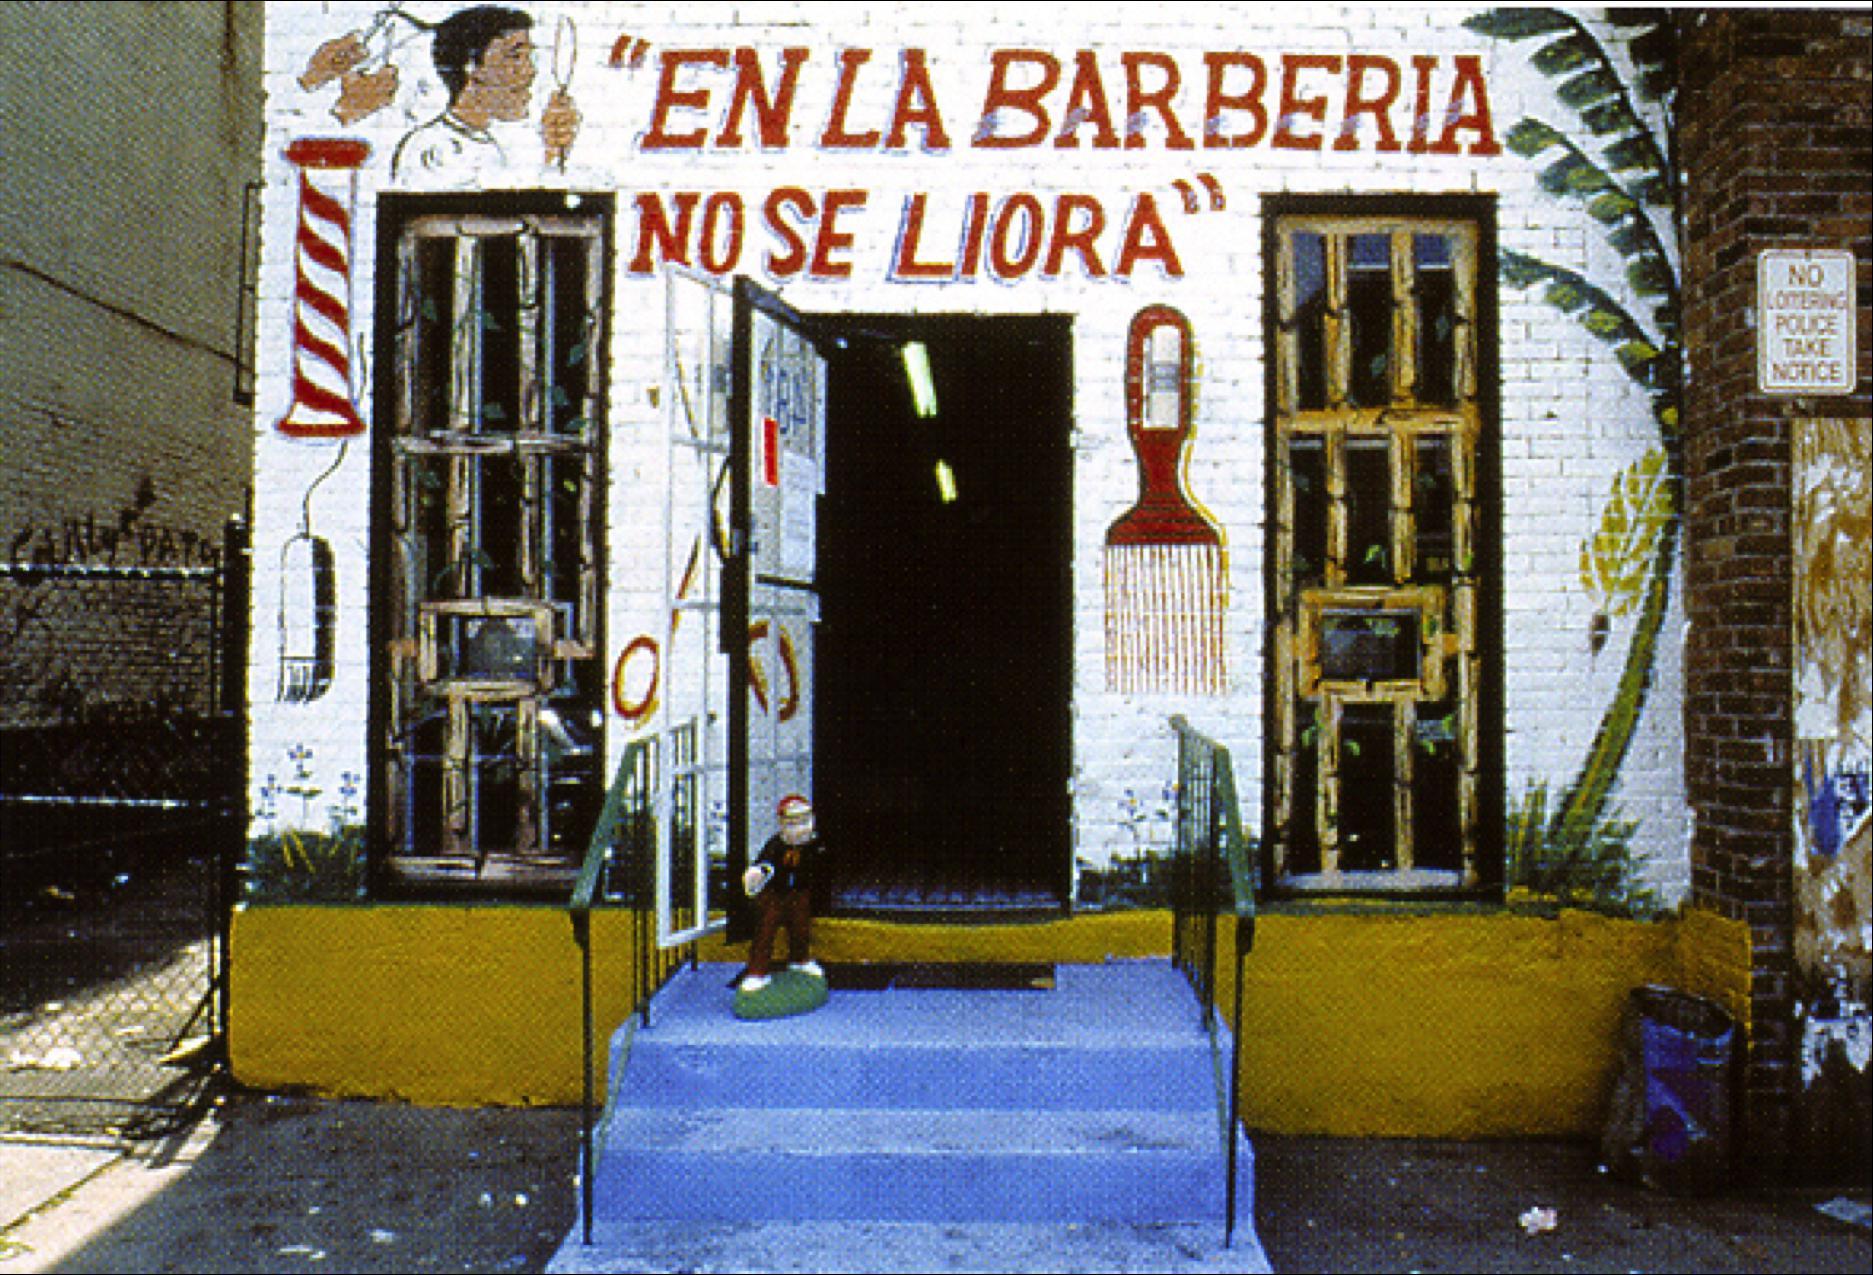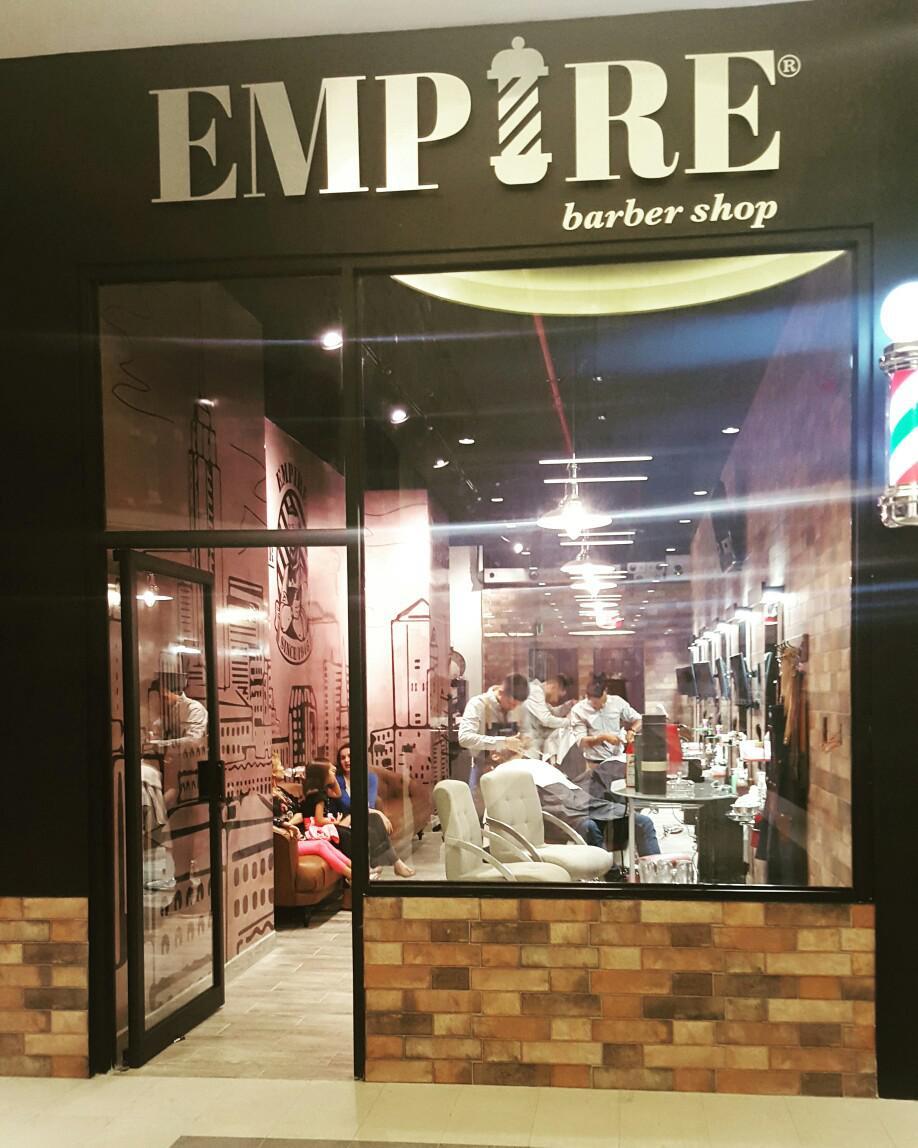The first image is the image on the left, the second image is the image on the right. Analyze the images presented: Is the assertion "There is a barber pole in the image on the left." valid? Answer yes or no. Yes. 